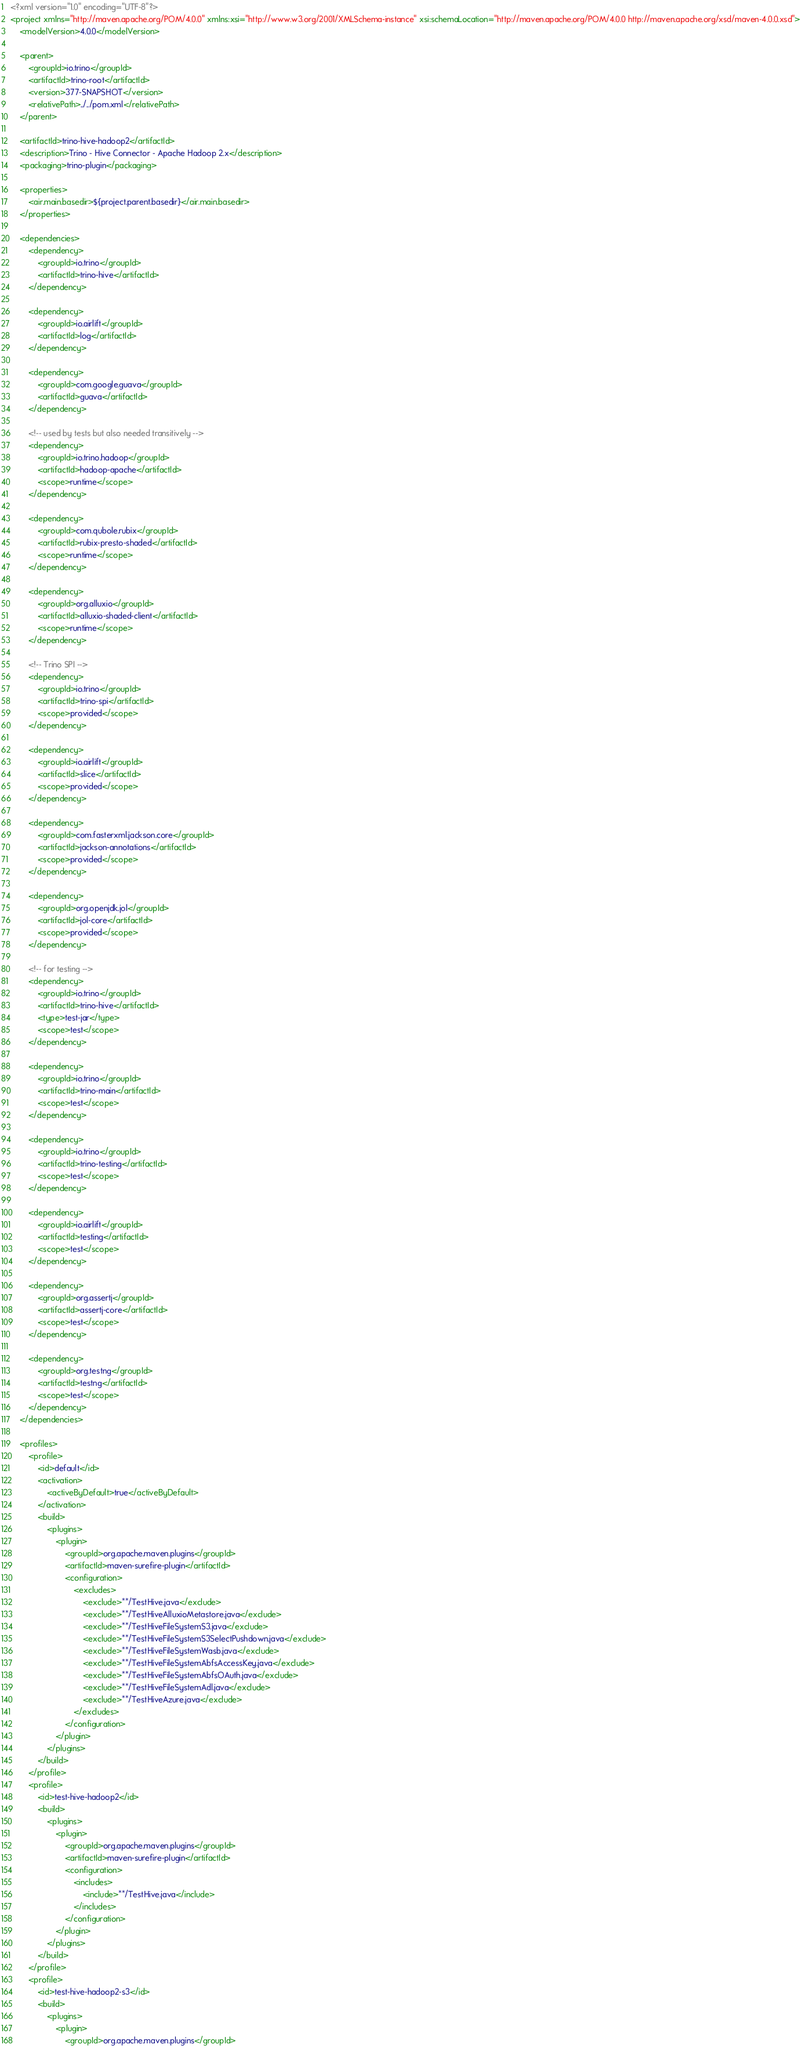<code> <loc_0><loc_0><loc_500><loc_500><_XML_><?xml version="1.0" encoding="UTF-8"?>
<project xmlns="http://maven.apache.org/POM/4.0.0" xmlns:xsi="http://www.w3.org/2001/XMLSchema-instance" xsi:schemaLocation="http://maven.apache.org/POM/4.0.0 http://maven.apache.org/xsd/maven-4.0.0.xsd">
    <modelVersion>4.0.0</modelVersion>

    <parent>
        <groupId>io.trino</groupId>
        <artifactId>trino-root</artifactId>
        <version>377-SNAPSHOT</version>
        <relativePath>../../pom.xml</relativePath>
    </parent>

    <artifactId>trino-hive-hadoop2</artifactId>
    <description>Trino - Hive Connector - Apache Hadoop 2.x</description>
    <packaging>trino-plugin</packaging>

    <properties>
        <air.main.basedir>${project.parent.basedir}</air.main.basedir>
    </properties>

    <dependencies>
        <dependency>
            <groupId>io.trino</groupId>
            <artifactId>trino-hive</artifactId>
        </dependency>

        <dependency>
            <groupId>io.airlift</groupId>
            <artifactId>log</artifactId>
        </dependency>

        <dependency>
            <groupId>com.google.guava</groupId>
            <artifactId>guava</artifactId>
        </dependency>

        <!-- used by tests but also needed transitively -->
        <dependency>
            <groupId>io.trino.hadoop</groupId>
            <artifactId>hadoop-apache</artifactId>
            <scope>runtime</scope>
        </dependency>

        <dependency>
            <groupId>com.qubole.rubix</groupId>
            <artifactId>rubix-presto-shaded</artifactId>
            <scope>runtime</scope>
        </dependency>

        <dependency>
            <groupId>org.alluxio</groupId>
            <artifactId>alluxio-shaded-client</artifactId>
            <scope>runtime</scope>
        </dependency>

        <!-- Trino SPI -->
        <dependency>
            <groupId>io.trino</groupId>
            <artifactId>trino-spi</artifactId>
            <scope>provided</scope>
        </dependency>

        <dependency>
            <groupId>io.airlift</groupId>
            <artifactId>slice</artifactId>
            <scope>provided</scope>
        </dependency>

        <dependency>
            <groupId>com.fasterxml.jackson.core</groupId>
            <artifactId>jackson-annotations</artifactId>
            <scope>provided</scope>
        </dependency>

        <dependency>
            <groupId>org.openjdk.jol</groupId>
            <artifactId>jol-core</artifactId>
            <scope>provided</scope>
        </dependency>

        <!-- for testing -->
        <dependency>
            <groupId>io.trino</groupId>
            <artifactId>trino-hive</artifactId>
            <type>test-jar</type>
            <scope>test</scope>
        </dependency>

        <dependency>
            <groupId>io.trino</groupId>
            <artifactId>trino-main</artifactId>
            <scope>test</scope>
        </dependency>

        <dependency>
            <groupId>io.trino</groupId>
            <artifactId>trino-testing</artifactId>
            <scope>test</scope>
        </dependency>

        <dependency>
            <groupId>io.airlift</groupId>
            <artifactId>testing</artifactId>
            <scope>test</scope>
        </dependency>

        <dependency>
            <groupId>org.assertj</groupId>
            <artifactId>assertj-core</artifactId>
            <scope>test</scope>
        </dependency>

        <dependency>
            <groupId>org.testng</groupId>
            <artifactId>testng</artifactId>
            <scope>test</scope>
        </dependency>
    </dependencies>

    <profiles>
        <profile>
            <id>default</id>
            <activation>
                <activeByDefault>true</activeByDefault>
            </activation>
            <build>
                <plugins>
                    <plugin>
                        <groupId>org.apache.maven.plugins</groupId>
                        <artifactId>maven-surefire-plugin</artifactId>
                        <configuration>
                            <excludes>
                                <exclude>**/TestHive.java</exclude>
                                <exclude>**/TestHiveAlluxioMetastore.java</exclude>
                                <exclude>**/TestHiveFileSystemS3.java</exclude>
                                <exclude>**/TestHiveFileSystemS3SelectPushdown.java</exclude>
                                <exclude>**/TestHiveFileSystemWasb.java</exclude>
                                <exclude>**/TestHiveFileSystemAbfsAccessKey.java</exclude>
                                <exclude>**/TestHiveFileSystemAbfsOAuth.java</exclude>
                                <exclude>**/TestHiveFileSystemAdl.java</exclude>
                                <exclude>**/TestHiveAzure.java</exclude>
                            </excludes>
                        </configuration>
                    </plugin>
                </plugins>
            </build>
        </profile>
        <profile>
            <id>test-hive-hadoop2</id>
            <build>
                <plugins>
                    <plugin>
                        <groupId>org.apache.maven.plugins</groupId>
                        <artifactId>maven-surefire-plugin</artifactId>
                        <configuration>
                            <includes>
                                <include>**/TestHive.java</include>
                            </includes>
                        </configuration>
                    </plugin>
                </plugins>
            </build>
        </profile>
        <profile>
            <id>test-hive-hadoop2-s3</id>
            <build>
                <plugins>
                    <plugin>
                        <groupId>org.apache.maven.plugins</groupId></code> 